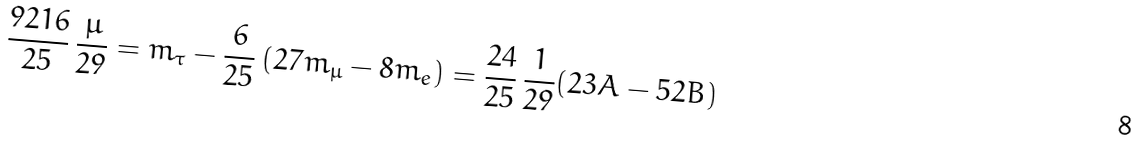<formula> <loc_0><loc_0><loc_500><loc_500>\frac { 9 2 1 6 } { 2 5 } \, \frac { \mu } { 2 9 } = m _ { \tau } - \frac { 6 } { 2 5 } \, ( 2 7 m _ { \mu } - 8 m _ { e } ) = \frac { 2 4 } { 2 5 } \, \frac { 1 } { 2 9 } ( 2 3 A - 5 2 B )</formula> 